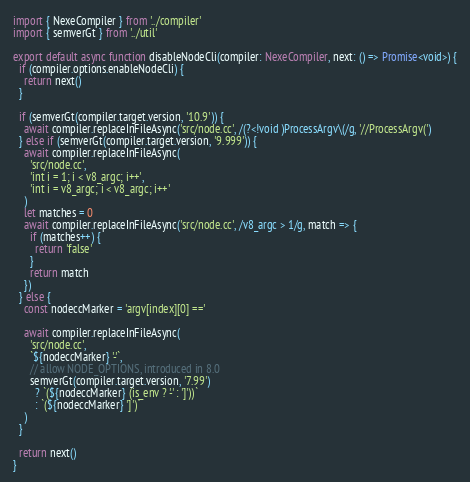<code> <loc_0><loc_0><loc_500><loc_500><_TypeScript_>import { NexeCompiler } from '../compiler'
import { semverGt } from '../util'

export default async function disableNodeCli(compiler: NexeCompiler, next: () => Promise<void>) {
  if (compiler.options.enableNodeCli) {
    return next()
  }

  if (semverGt(compiler.target.version, '10.9')) {
    await compiler.replaceInFileAsync('src/node.cc', /(?<!void )ProcessArgv\(/g, '//ProcessArgv(')
  } else if (semverGt(compiler.target.version, '9.999')) {
    await compiler.replaceInFileAsync(
      'src/node.cc',
      'int i = 1; i < v8_argc; i++',
      'int i = v8_argc; i < v8_argc; i++'
    )
    let matches = 0
    await compiler.replaceInFileAsync('src/node.cc', /v8_argc > 1/g, match => {
      if (matches++) {
        return 'false'
      }
      return match
    })
  } else {
    const nodeccMarker = 'argv[index][0] =='

    await compiler.replaceInFileAsync(
      'src/node.cc',
      `${nodeccMarker} '-'`,
      // allow NODE_OPTIONS, introduced in 8.0
      semverGt(compiler.target.version, '7.99')
        ? `(${nodeccMarker} (is_env ? '-' : ']'))`
        : `(${nodeccMarker} ']')`
    )
  }

  return next()
}
</code> 